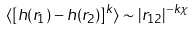<formula> <loc_0><loc_0><loc_500><loc_500>\langle [ h ( { r } _ { 1 } ) - h ( { r } _ { 2 } ) ] ^ { k } \rangle \sim | { r } _ { 1 2 } | ^ { - k \chi }</formula> 